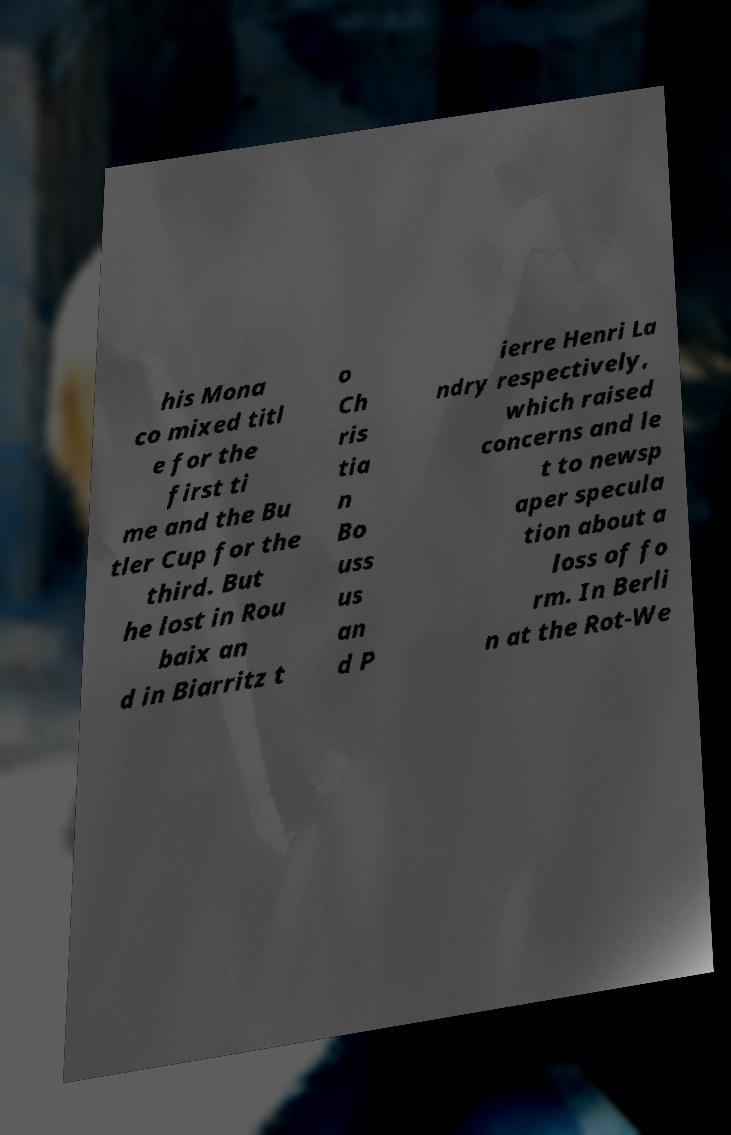Can you read and provide the text displayed in the image?This photo seems to have some interesting text. Can you extract and type it out for me? his Mona co mixed titl e for the first ti me and the Bu tler Cup for the third. But he lost in Rou baix an d in Biarritz t o Ch ris tia n Bo uss us an d P ierre Henri La ndry respectively, which raised concerns and le t to newsp aper specula tion about a loss of fo rm. In Berli n at the Rot-We 